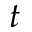Convert formula to latex. <formula><loc_0><loc_0><loc_500><loc_500>t</formula> 